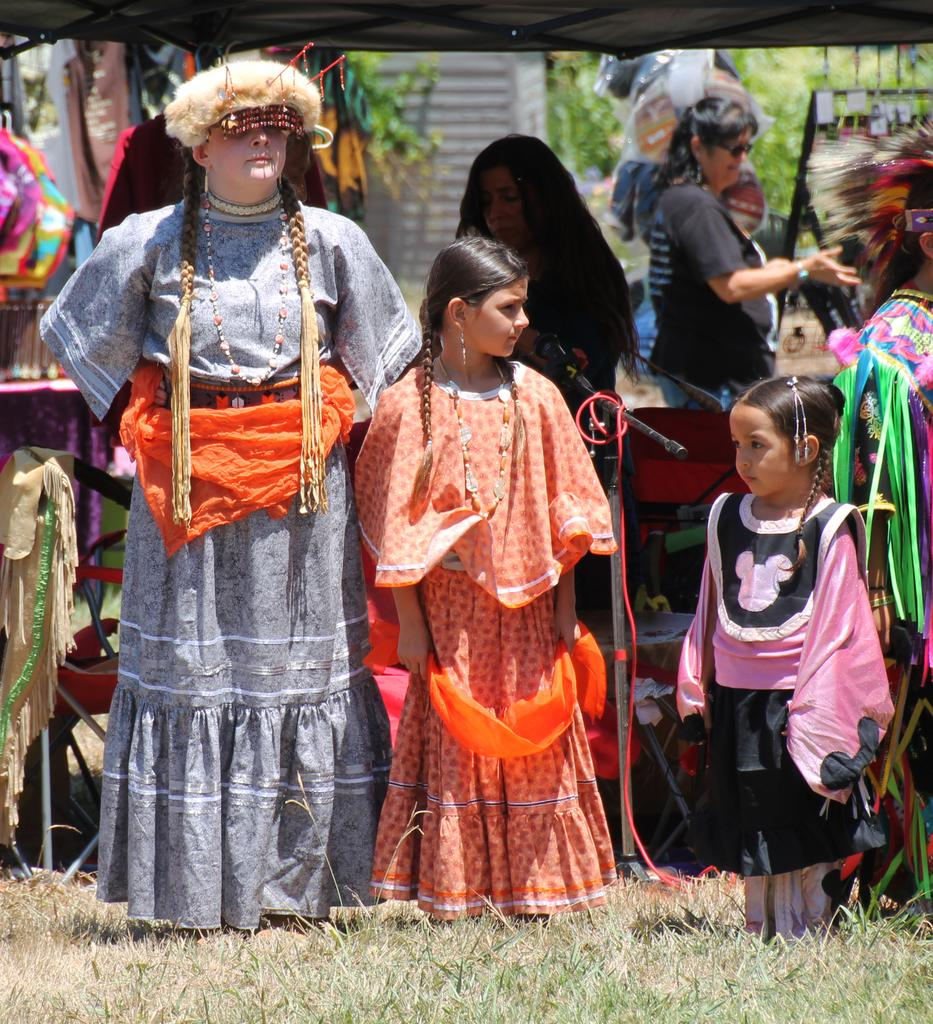What is happening in the center of the image? There are persons standing on the ground in the center of the image. What can be seen in the background of the image? There is a mic, a tub, clothes, women, additional persons, trees, and a wall in the background of the image. Where is the market located in the image? There is no market present in the image. What type of boundary can be seen in the image? There is no boundary visible in the image. 